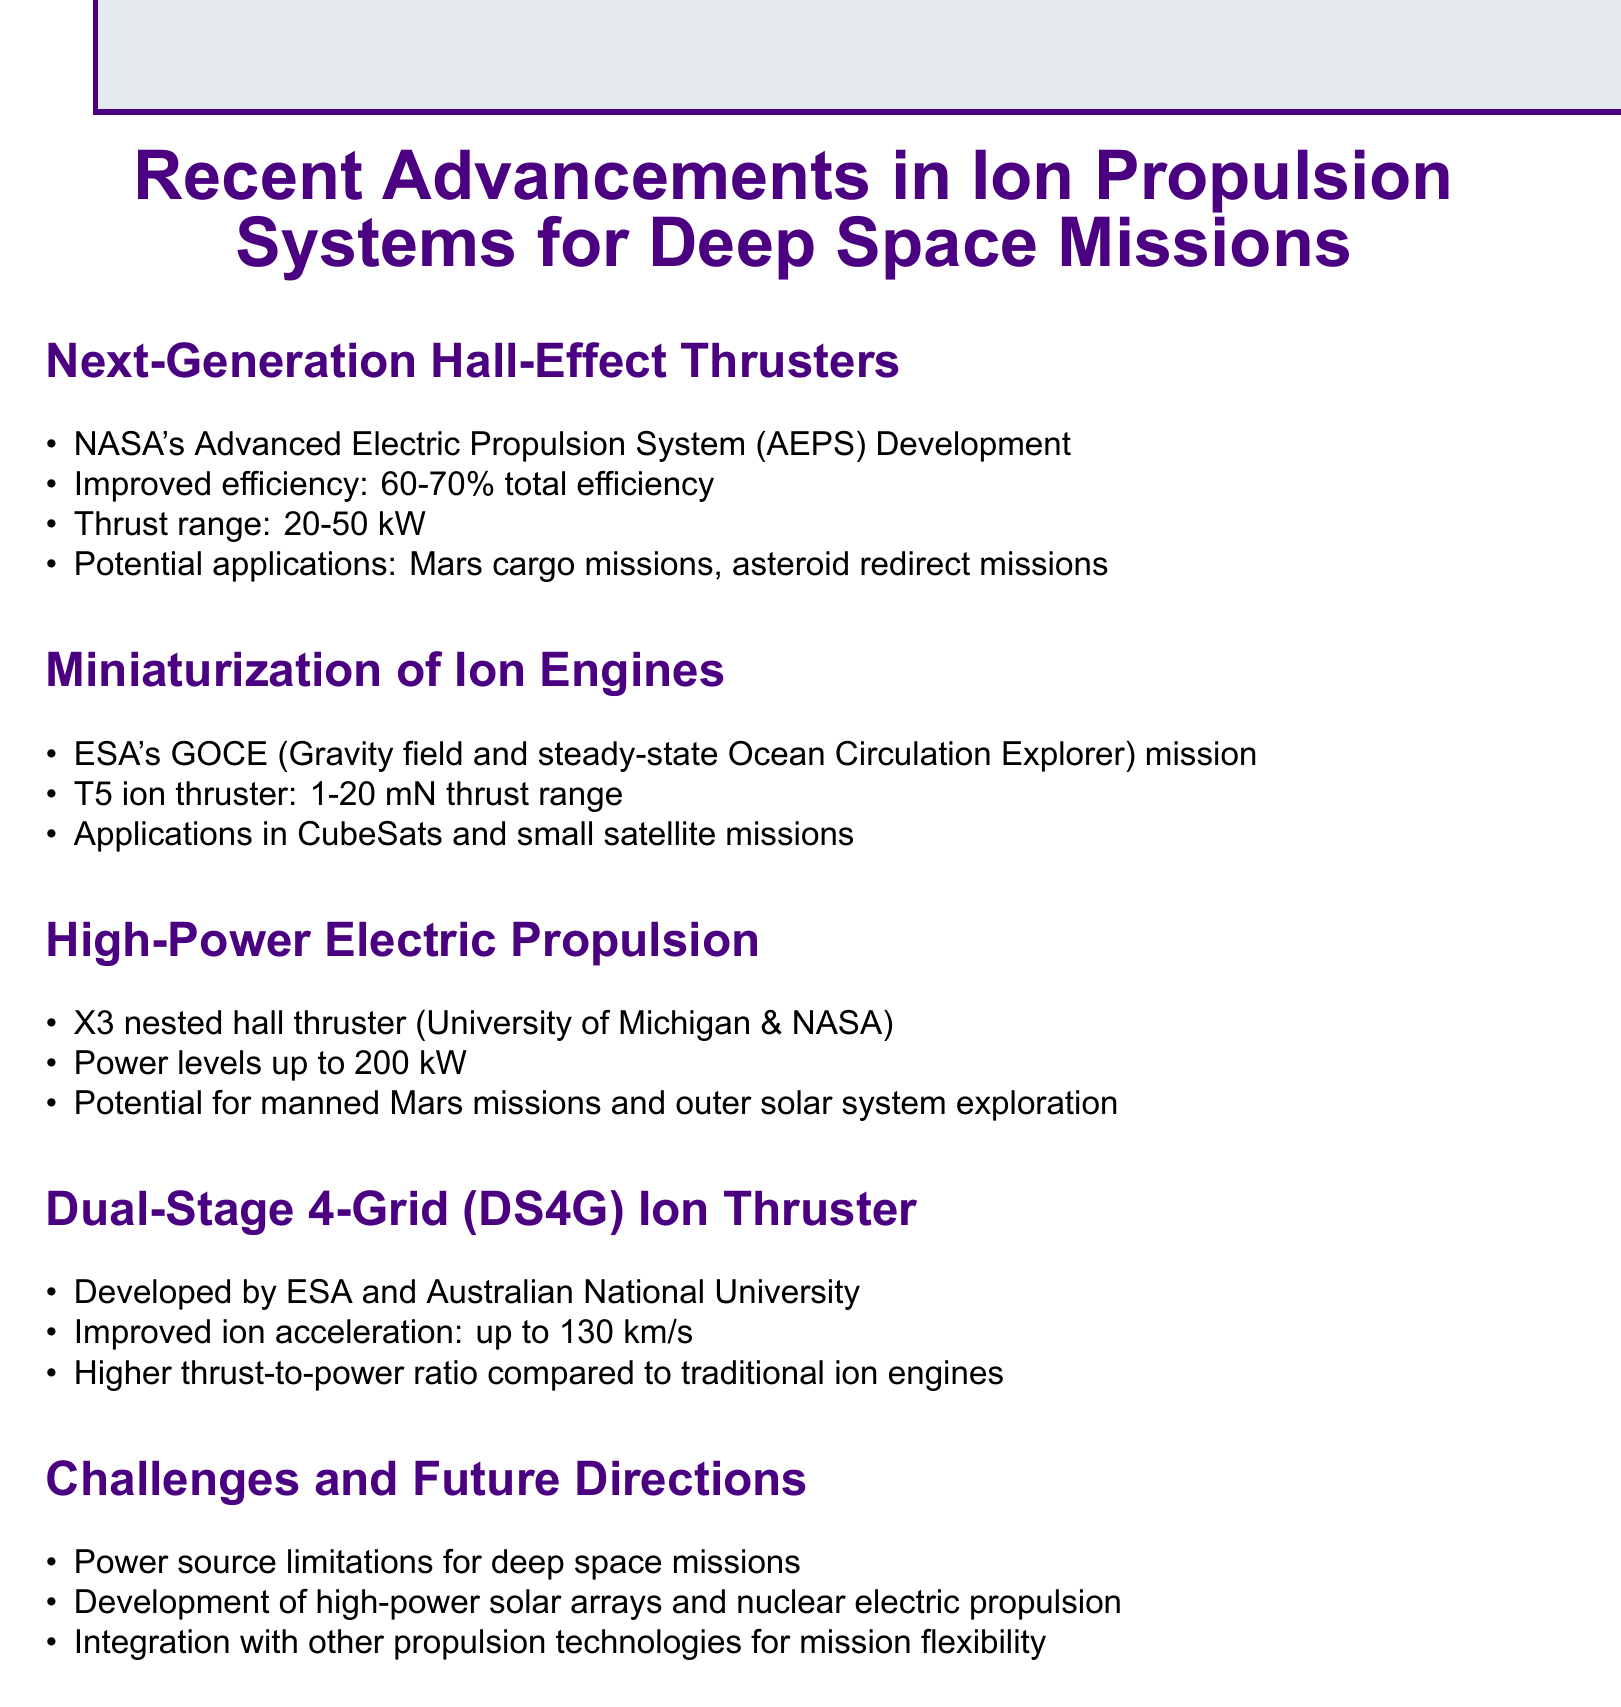What is the total efficiency range of the Next-Generation Hall-Effect Thrusters? The document states that the improved efficiency of the Next-Generation Hall-Effect Thrusters ranges from 60-70%.
Answer: 60-70% What is the thrust range of the T5 ion thruster? The T5 ion thruster mentioned in the miniaturization section has a thrust range of 1-20 mN.
Answer: 1-20 mN What is the power level of the X3 nested hall thruster? The document specifies that the X3 nested hall thruster can achieve power levels up to 200 kW.
Answer: 200 kW Which organization developed the Dual-Stage 4-Grid ion thruster? The Dual-Stage 4-Grid ion thruster was developed by ESA and the Australian National University.
Answer: ESA and Australian National University What is a major challenge for deep space missions identified in the document? The document lists power source limitations as a major challenge for deep space missions.
Answer: Power source limitations In what potential applications could Hall-Effect Thrusters be used? The potential applications for Hall-Effect Thrusters include Mars cargo missions and asteroid redirect missions according to the document.
Answer: Mars cargo missions, asteroid redirect missions What type of missions is the miniaturization of ion engines particularly useful for? The document indicates that the miniaturization of ion engines is particularly useful for CubeSats and small satellite missions.
Answer: CubeSats and small satellite missions What does DS4G stand for in the context of ion thrusters? The document refers to the DS4G as the Dual-Stage 4-Grid ion thruster.
Answer: Dual-Stage 4-Grid 